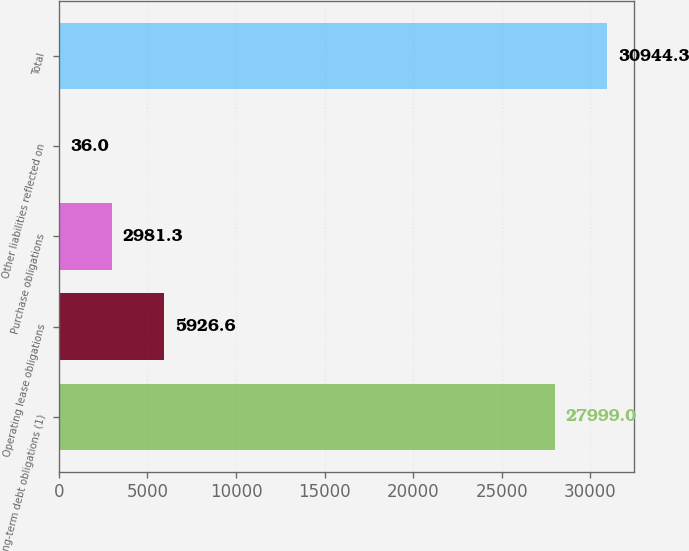Convert chart. <chart><loc_0><loc_0><loc_500><loc_500><bar_chart><fcel>Long-term debt obligations (1)<fcel>Operating lease obligations<fcel>Purchase obligations<fcel>Other liabilities reflected on<fcel>Total<nl><fcel>27999<fcel>5926.6<fcel>2981.3<fcel>36<fcel>30944.3<nl></chart> 